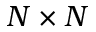<formula> <loc_0><loc_0><loc_500><loc_500>N \times N</formula> 